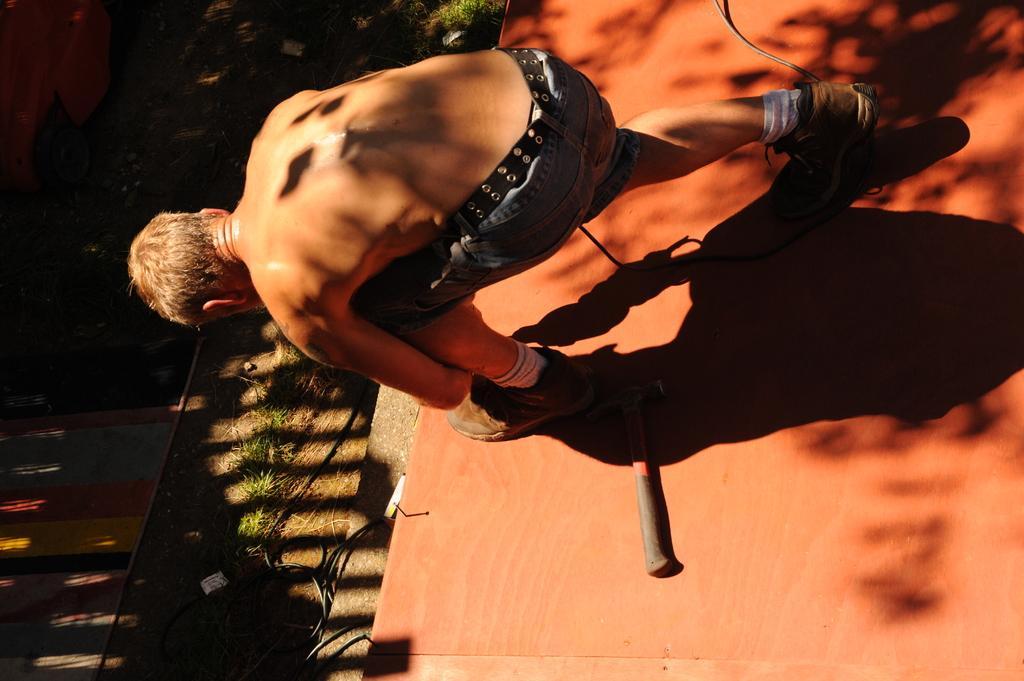Can you describe this image briefly? In the image there is a man bending and tying the shoelace, behind the man there is a hammer and in front of the man there is some grass on the ground. 